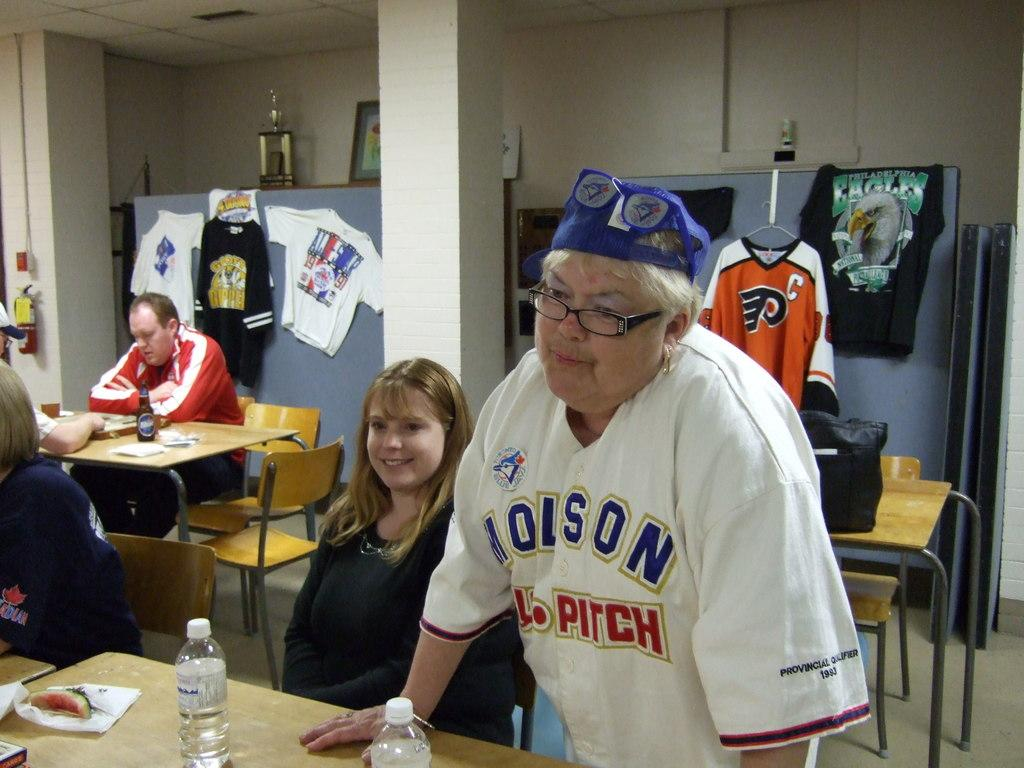What are the people in the image doing? The people in the image are sitting at a table. Can you describe the woman in the image? There is a woman standing in the image. What is hanging on the door in the background of the image? T-shirts are attached to a door in the background of the image. What type of ice can be seen melting on the table in the image? There is no ice present on the table in the image. How many buttons are visible on the woman's shirt in the image? The image does not show the woman's shirt, so it is not possible to determine the number of buttons. --- Facts: 1. There is a car in the image. 2. The car is parked on the street. 3. There are trees on both sides of the street. 4. The sky is visible in the image. Absurd Topics: fish, piano, mountain Conversation: What is the main subject of the image? The main subject of the image is a car. Where is the car located in the image? The car is parked on the street. What can be seen on both sides of the street in the image? There are trees on both sides of the street. What is visible in the background of the image? The sky is visible in the image. Reasoning: Let's think step by step in order to produce the conversation. We start by identifying the main subject of the image, which is the car. Then, we describe the car's location and the surrounding environment, including the trees on both sides of the street. Finally, we mention the sky visible in the background. Absurd Question/Answer: Can you tell me how many fish are swimming in the river in the image? There is no river or fish present in the image; it features a car parked on the street with trees on both sides and the sky visible in the background. What type of piano can be seen in the image? There is no piano present in the image. 